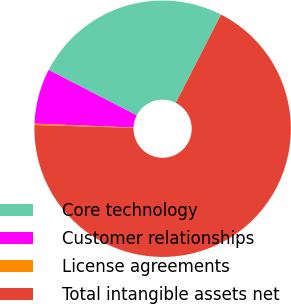Convert chart to OTSL. <chart><loc_0><loc_0><loc_500><loc_500><pie_chart><fcel>Core technology<fcel>Customer relationships<fcel>License agreements<fcel>Total intangible assets net<nl><fcel>24.95%<fcel>6.95%<fcel>0.17%<fcel>67.93%<nl></chart> 